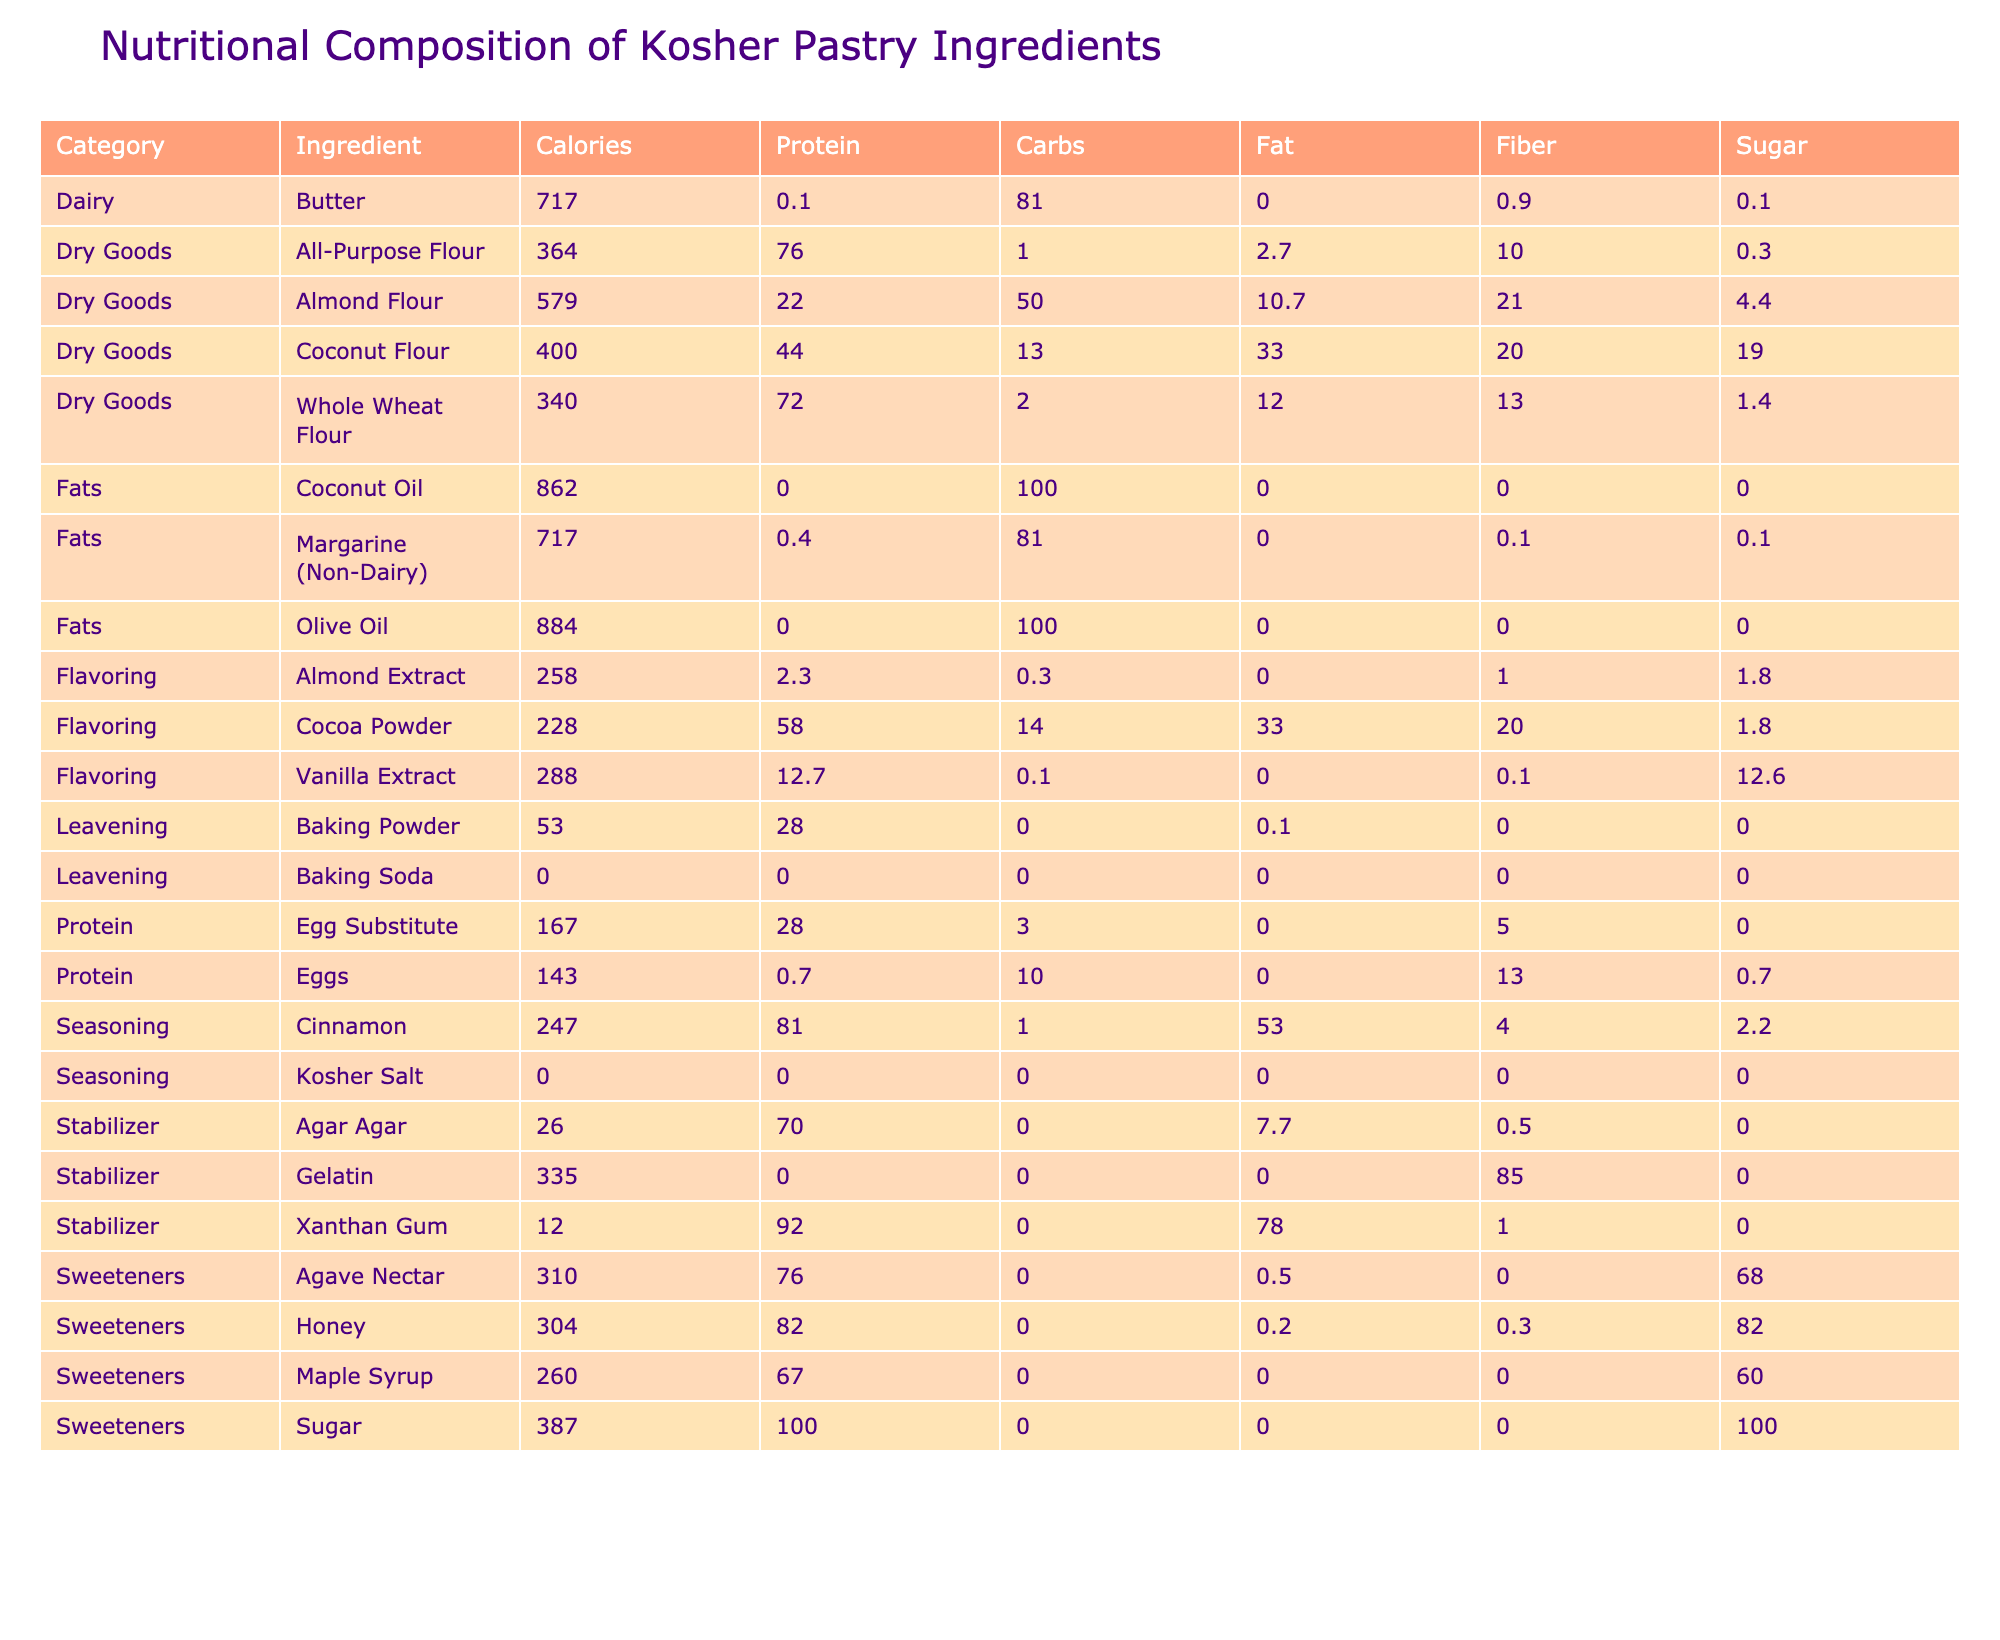What is the highest calorie ingredient listed in the table? By examining the "Calories (per 100g)" column, I identify that Almond Flour has 579 calories, and Coconut Oil has 862 calories. Since 862 is greater than 579, Coconut Oil is the ingredient with the highest calories.
Answer: Coconut Oil Which ingredient contains the most protein? Looking at the "Protein (g)" column, I see that Gelatin has the highest protein content at 85 grams. This value is compared to other protein-containing ingredients in the table.
Answer: Gelatin Are all the sweeteners kosher certified? I check the "Kosher Certification" column for each sweetener: Sugar (OU), Honey (OK), Maple Syrup (COR), and Agave Nectar (Star-K). Since Maple Syrup has COR certification, which is not OU, not all sweeteners are certified kosher.
Answer: No What is the average sugar content of all dry goods? To find the average sugar content, I first list the sugar values for all dry goods: All-Purpose Flour (0.3 g), Whole Wheat Flour (1.4 g), Almond Flour (4.4 g), Coconut Flour (19 g). Adding these values gives 25.1 g. Then I divide by 4 (the number of dry goods) to get an average of 6.275 g.
Answer: 6.3 g Which fat contains the least amount of protein? In the "Protein (g)" column under fats, I find Coconut Oil has 0 g of protein while Olive Oil also has 0 g of protein. Both have the least protein content, and thus they tie for this criterion.
Answer: Coconut Oil and Olive Oil What is the total carbohydrate content of all sweeteners combined? Summing the "Carbohydrates (g)" for the sweeteners: Sugar (100 g), Honey (82 g), Maple Syrup (67 g), and Agave Nectar (76 g) gives a total of 325 g (100 + 82 + 67 + 76 = 325). This is the total carbohydrate content of all sweeteners.
Answer: 325 g Does Cocoa Powder have more fiber than Coconut Flour? Checking the "Fiber (g)" column: Cocoa Powder has 14 g of fiber and Coconut Flour has 33 g. Since 33 is greater than 14, Cocoa Powder does not have more fiber than Coconut Flour.
Answer: No Which ingredient has the highest fat content? By reviewing the "Fat (g)" column, I find that Coconut Oil and Olive Oil both contain 100 g of fat, making them the highest fat content ingredients in the table.
Answer: Coconut Oil and Olive Oil 